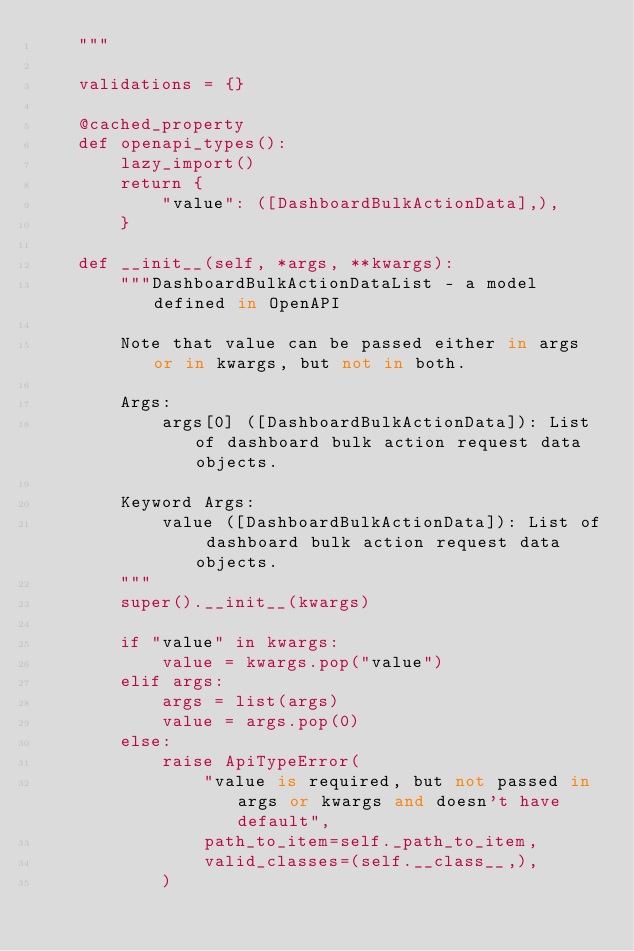Convert code to text. <code><loc_0><loc_0><loc_500><loc_500><_Python_>    """

    validations = {}

    @cached_property
    def openapi_types():
        lazy_import()
        return {
            "value": ([DashboardBulkActionData],),
        }

    def __init__(self, *args, **kwargs):
        """DashboardBulkActionDataList - a model defined in OpenAPI

        Note that value can be passed either in args or in kwargs, but not in both.

        Args:
            args[0] ([DashboardBulkActionData]): List of dashboard bulk action request data objects.

        Keyword Args:
            value ([DashboardBulkActionData]): List of dashboard bulk action request data objects.
        """
        super().__init__(kwargs)

        if "value" in kwargs:
            value = kwargs.pop("value")
        elif args:
            args = list(args)
            value = args.pop(0)
        else:
            raise ApiTypeError(
                "value is required, but not passed in args or kwargs and doesn't have default",
                path_to_item=self._path_to_item,
                valid_classes=(self.__class__,),
            )
</code> 